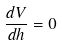<formula> <loc_0><loc_0><loc_500><loc_500>\frac { d V } { d h } = 0</formula> 